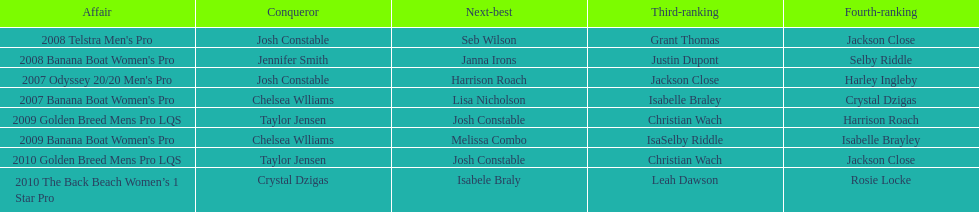Name each of the years that taylor jensen was winner. 2009, 2010. 